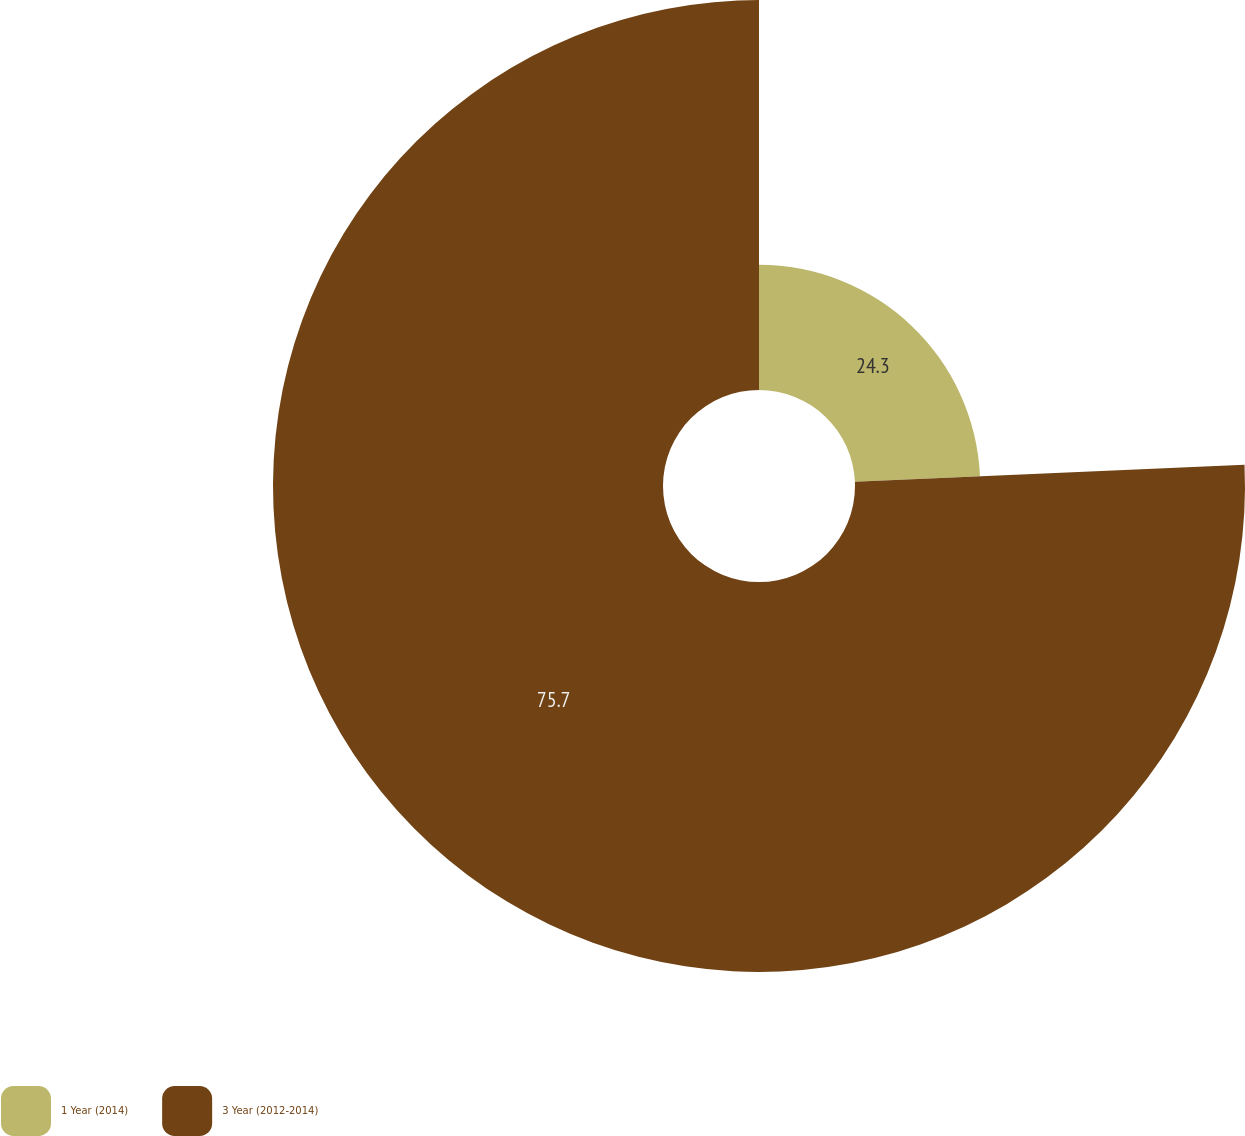<chart> <loc_0><loc_0><loc_500><loc_500><pie_chart><fcel>1 Year (2014)<fcel>3 Year (2012-2014)<nl><fcel>24.3%<fcel>75.7%<nl></chart> 